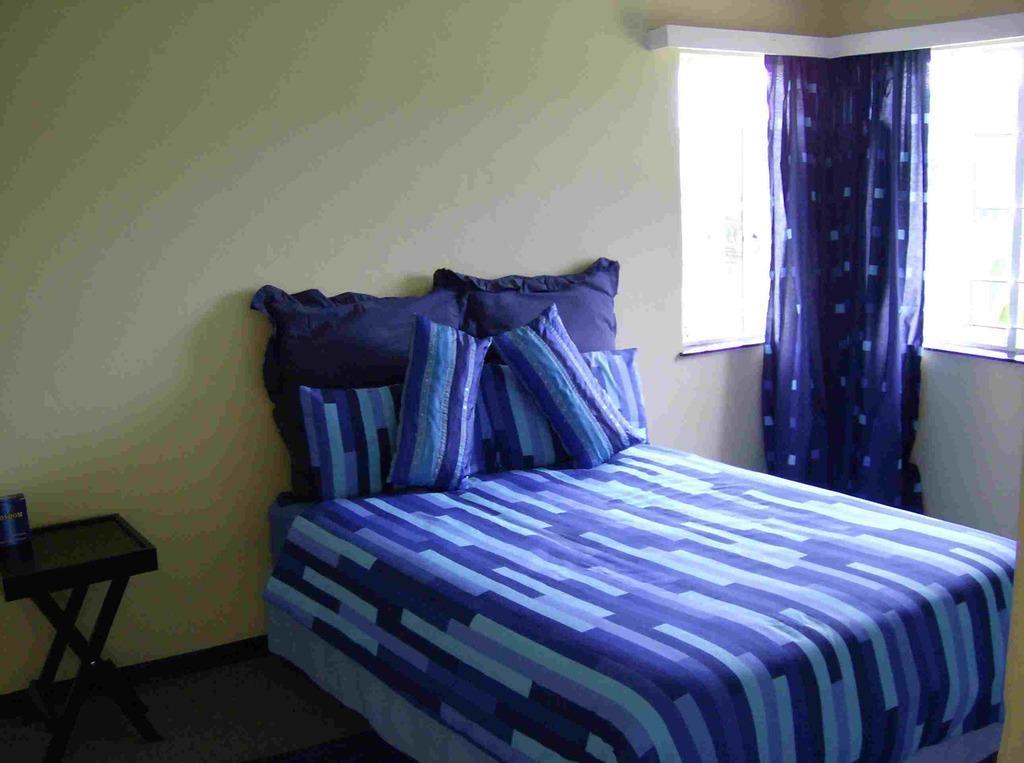Can you describe this image briefly? There is a bed and pillow on room and at corner there and table and tin on it at one corner there is a window with curtains hanging. 